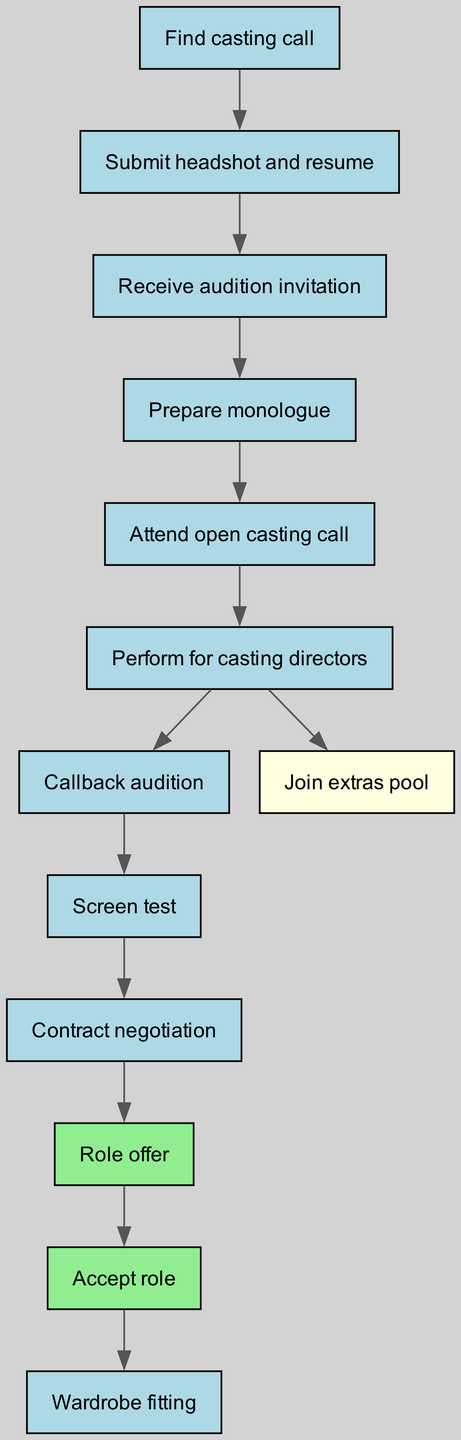What is the first step in the audition process? The first step in the audition process is represented by the node "Find casting call." It indicates the initial action an aspiring actor must take to get started.
Answer: Find casting call How many nodes are in the diagram? By counting the nodes listed in the diagram, we find there are 12 distinct steps in the audition process.
Answer: 12 What connects "Perform for casting directors" to "Join extras pool"? The edge between "Perform for casting directors" and "Join extras pool" indicates that if an actor performs for the casting directors, they have the option to join the extras pool as an alternative outcome.
Answer: Join extras pool What is the last step if the role is accepted? The final step after accepting the role is "Wardrobe fitting." It shows what happens immediately following the acceptance of a role.
Answer: Wardrobe fitting How many edges are in the diagram? By examining the edges defined in the diagram between the nodes, we see that there are 11 connections, indicating the flow of the audition process.
Answer: 11 What is the relationship between "Callback audition" and "Screen test"? The "Callback audition" leads directly to "Screen test," meaning that if an actor successfully makes it to a callback, they will move on to the next step, which is the screen test.
Answer: Screen test Which nodes are highlighted in green? The nodes "Role offer" and "Accept role" are specifically highlighted in green, indicating their importance in the flow of accepting a role in a production.
Answer: Role offer, Accept role What step follows "Screen test" in the process? After completing the "Screen test," the next step is "Contract negotiation," which is essential for finalizing the terms of participation in the film.
Answer: Contract negotiation Which node represents an alternative outcome from the casting directors? The node "Join extras pool" represents an alternative outcome, where actors can still participate in the film as extras, rather than securing a specific role.
Answer: Join extras pool 